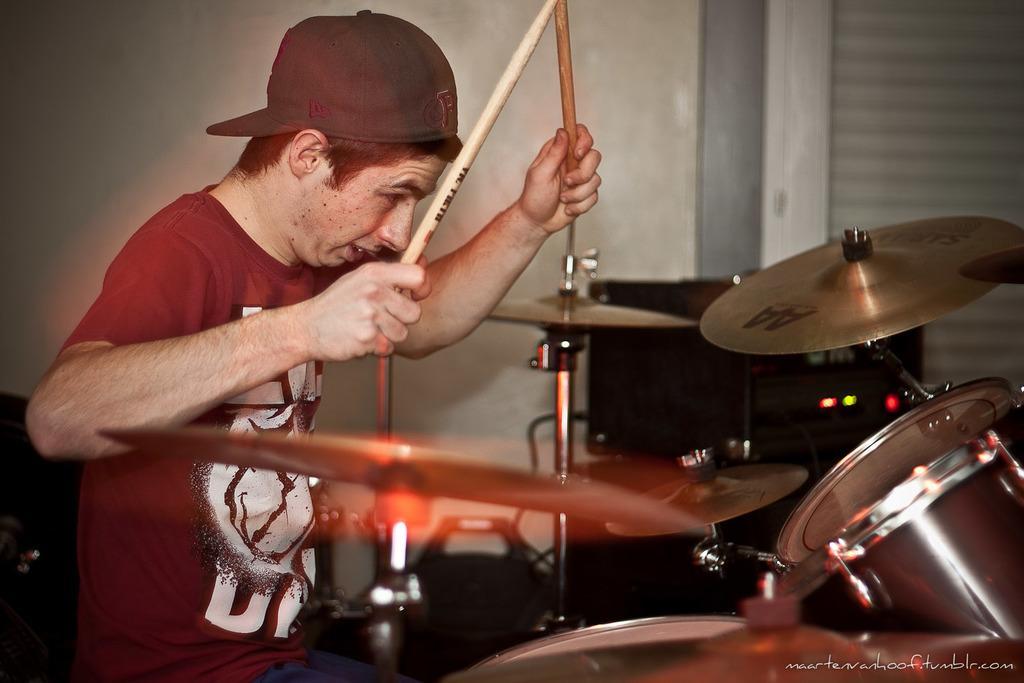Describe this image in one or two sentences. This person is sitting on a chair and plays a musical instruments. This person holds sticks and wire cap. This are electronic devices. 